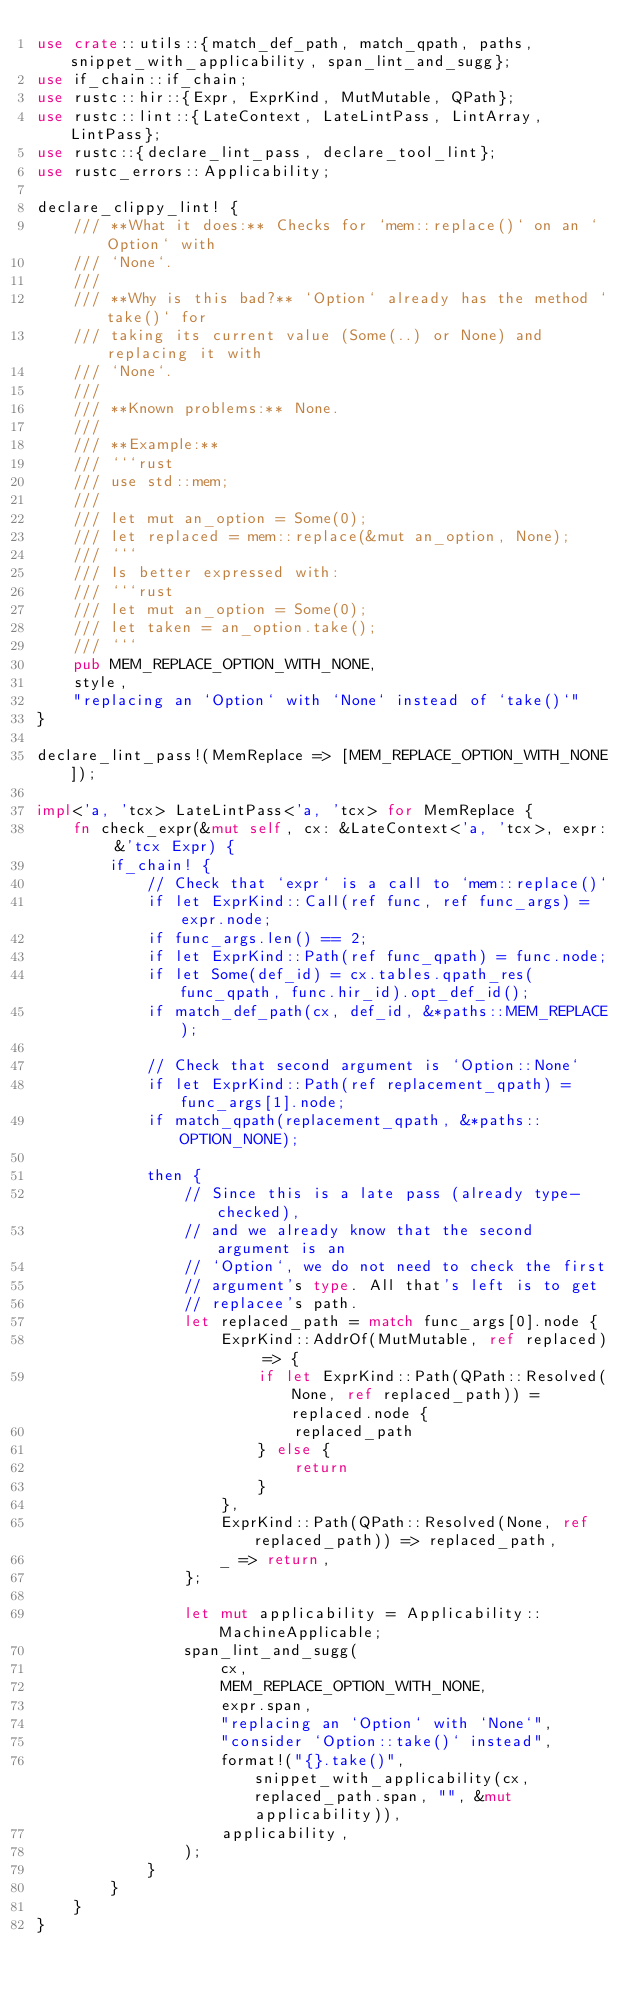Convert code to text. <code><loc_0><loc_0><loc_500><loc_500><_Rust_>use crate::utils::{match_def_path, match_qpath, paths, snippet_with_applicability, span_lint_and_sugg};
use if_chain::if_chain;
use rustc::hir::{Expr, ExprKind, MutMutable, QPath};
use rustc::lint::{LateContext, LateLintPass, LintArray, LintPass};
use rustc::{declare_lint_pass, declare_tool_lint};
use rustc_errors::Applicability;

declare_clippy_lint! {
    /// **What it does:** Checks for `mem::replace()` on an `Option` with
    /// `None`.
    ///
    /// **Why is this bad?** `Option` already has the method `take()` for
    /// taking its current value (Some(..) or None) and replacing it with
    /// `None`.
    ///
    /// **Known problems:** None.
    ///
    /// **Example:**
    /// ```rust
    /// use std::mem;
    ///
    /// let mut an_option = Some(0);
    /// let replaced = mem::replace(&mut an_option, None);
    /// ```
    /// Is better expressed with:
    /// ```rust
    /// let mut an_option = Some(0);
    /// let taken = an_option.take();
    /// ```
    pub MEM_REPLACE_OPTION_WITH_NONE,
    style,
    "replacing an `Option` with `None` instead of `take()`"
}

declare_lint_pass!(MemReplace => [MEM_REPLACE_OPTION_WITH_NONE]);

impl<'a, 'tcx> LateLintPass<'a, 'tcx> for MemReplace {
    fn check_expr(&mut self, cx: &LateContext<'a, 'tcx>, expr: &'tcx Expr) {
        if_chain! {
            // Check that `expr` is a call to `mem::replace()`
            if let ExprKind::Call(ref func, ref func_args) = expr.node;
            if func_args.len() == 2;
            if let ExprKind::Path(ref func_qpath) = func.node;
            if let Some(def_id) = cx.tables.qpath_res(func_qpath, func.hir_id).opt_def_id();
            if match_def_path(cx, def_id, &*paths::MEM_REPLACE);

            // Check that second argument is `Option::None`
            if let ExprKind::Path(ref replacement_qpath) = func_args[1].node;
            if match_qpath(replacement_qpath, &*paths::OPTION_NONE);

            then {
                // Since this is a late pass (already type-checked),
                // and we already know that the second argument is an
                // `Option`, we do not need to check the first
                // argument's type. All that's left is to get
                // replacee's path.
                let replaced_path = match func_args[0].node {
                    ExprKind::AddrOf(MutMutable, ref replaced) => {
                        if let ExprKind::Path(QPath::Resolved(None, ref replaced_path)) = replaced.node {
                            replaced_path
                        } else {
                            return
                        }
                    },
                    ExprKind::Path(QPath::Resolved(None, ref replaced_path)) => replaced_path,
                    _ => return,
                };

                let mut applicability = Applicability::MachineApplicable;
                span_lint_and_sugg(
                    cx,
                    MEM_REPLACE_OPTION_WITH_NONE,
                    expr.span,
                    "replacing an `Option` with `None`",
                    "consider `Option::take()` instead",
                    format!("{}.take()", snippet_with_applicability(cx, replaced_path.span, "", &mut applicability)),
                    applicability,
                );
            }
        }
    }
}
</code> 